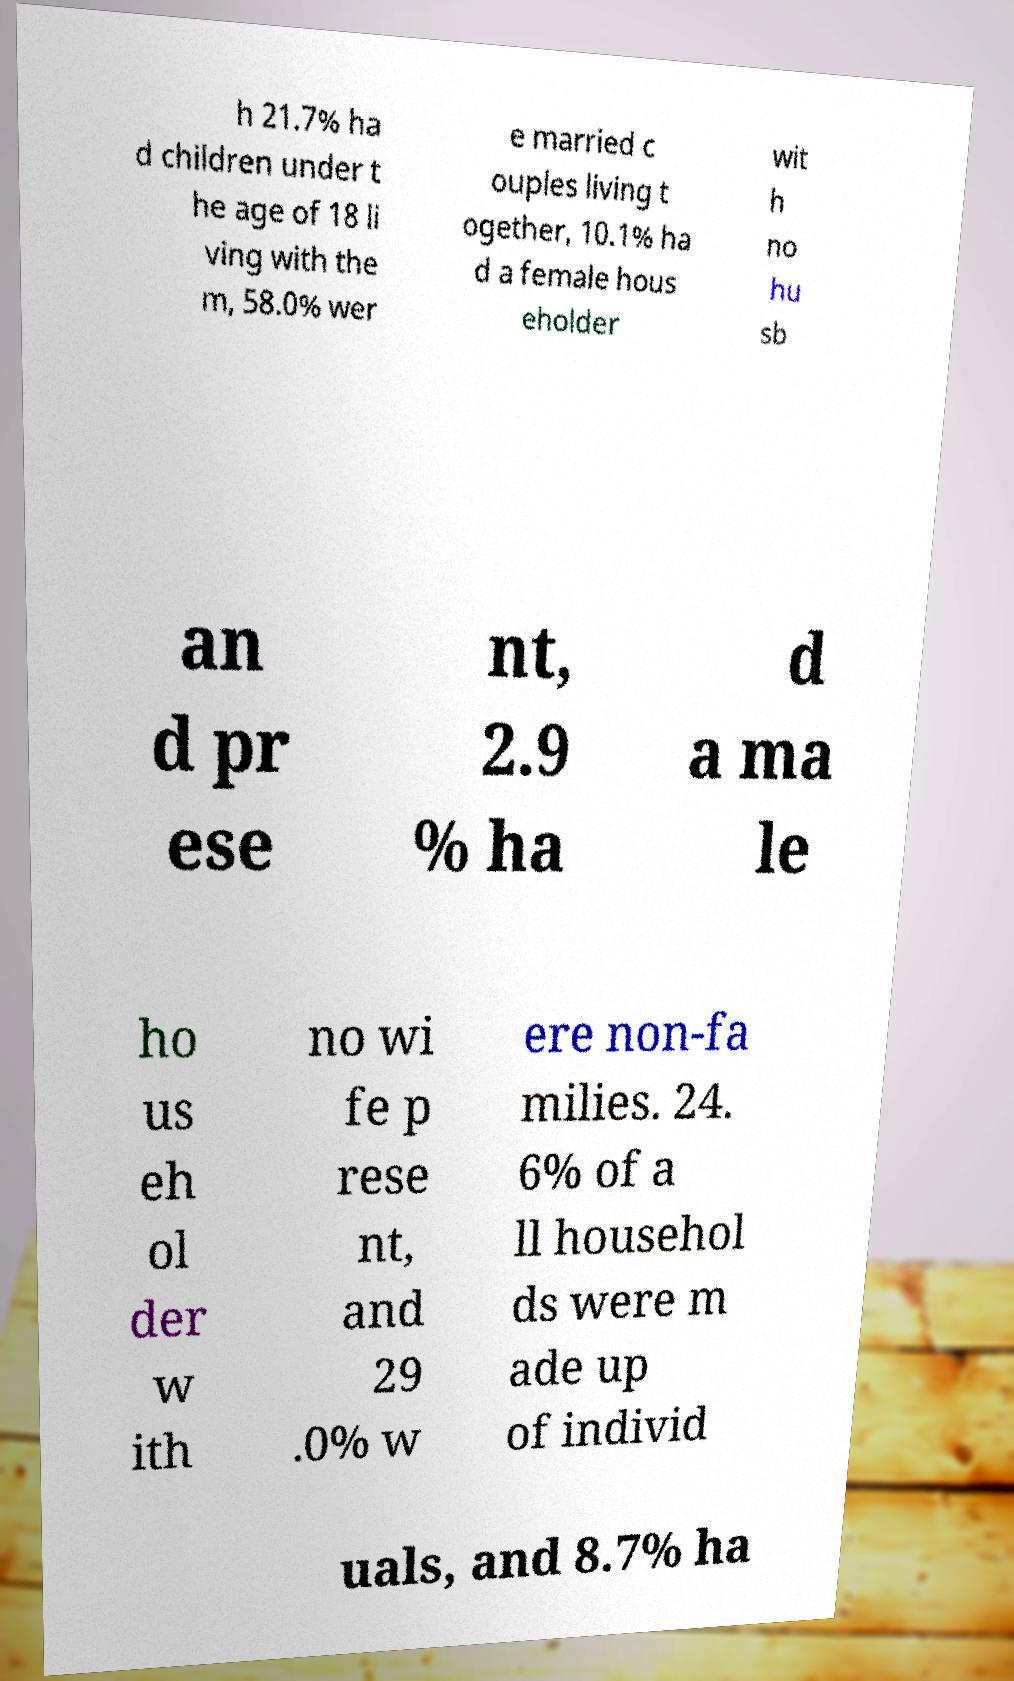Can you accurately transcribe the text from the provided image for me? h 21.7% ha d children under t he age of 18 li ving with the m, 58.0% wer e married c ouples living t ogether, 10.1% ha d a female hous eholder wit h no hu sb an d pr ese nt, 2.9 % ha d a ma le ho us eh ol der w ith no wi fe p rese nt, and 29 .0% w ere non-fa milies. 24. 6% of a ll househol ds were m ade up of individ uals, and 8.7% ha 